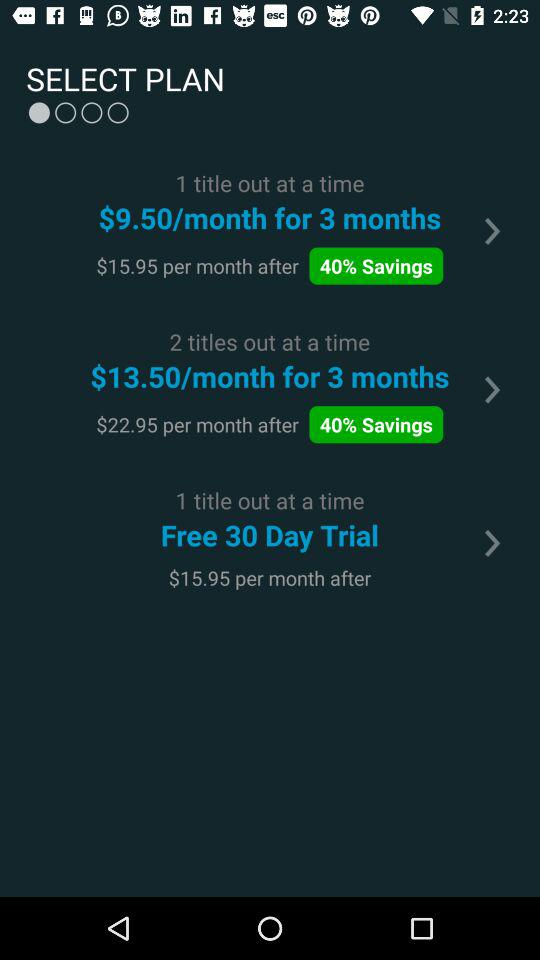How many plans are there?
Answer the question using a single word or phrase. 3 